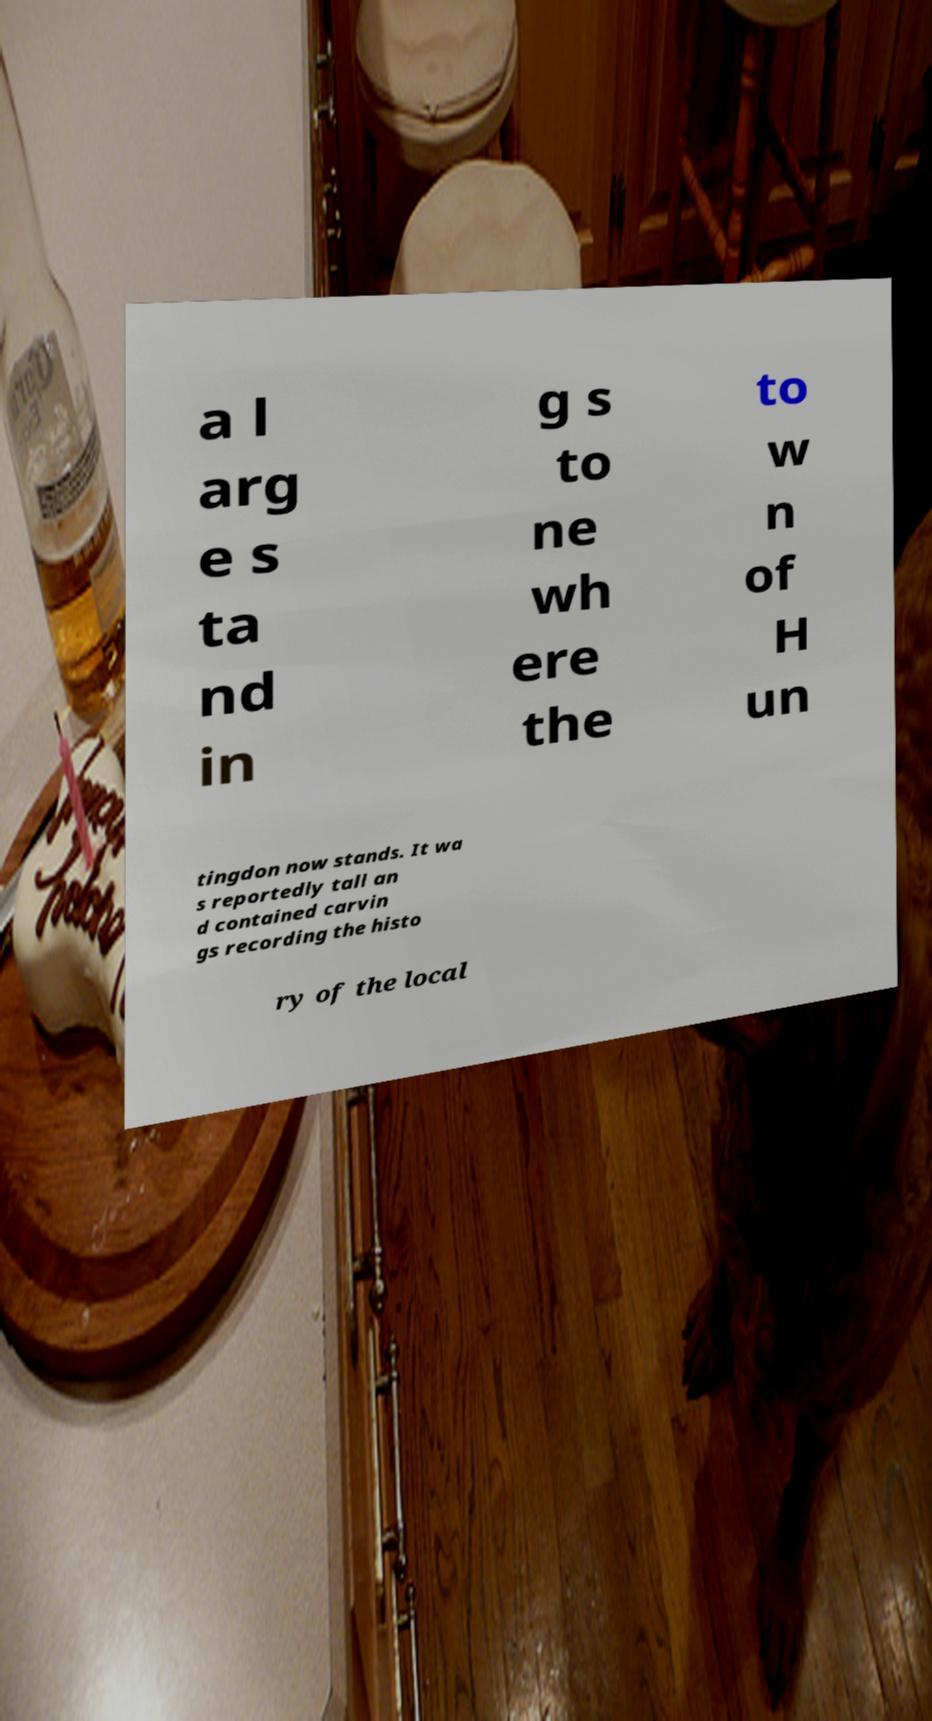Can you read and provide the text displayed in the image?This photo seems to have some interesting text. Can you extract and type it out for me? a l arg e s ta nd in g s to ne wh ere the to w n of H un tingdon now stands. It wa s reportedly tall an d contained carvin gs recording the histo ry of the local 